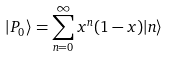<formula> <loc_0><loc_0><loc_500><loc_500>| P _ { 0 } \rangle = \sum _ { n = 0 } ^ { \infty } x ^ { n } ( 1 - x ) | n \rangle</formula> 